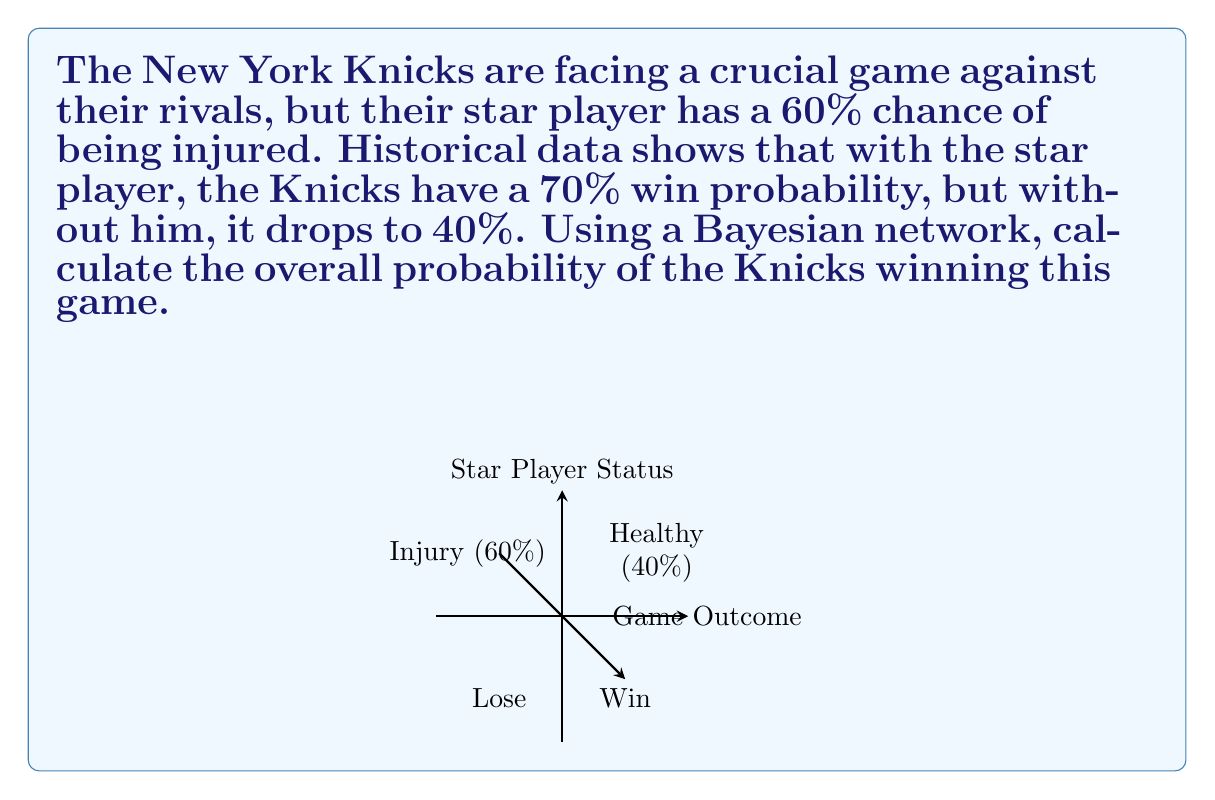Provide a solution to this math problem. Let's approach this step-by-step using Bayesian probability:

1) Define our events:
   I: Star player is injured
   W: Knicks win the game

2) Given probabilities:
   P(I) = 0.60 (60% chance of injury)
   P(W|I) = 0.40 (40% win probability if injured)
   P(W|not I) = 0.70 (70% win probability if not injured)

3) We need to find P(W), which can be calculated using the law of total probability:

   $$P(W) = P(W|I) \cdot P(I) + P(W|\text{not }I) \cdot P(\text{not }I)$$

4) We know P(I) = 0.60, so P(not I) = 1 - 0.60 = 0.40

5) Now, let's substitute the values:

   $$P(W) = 0.40 \cdot 0.60 + 0.70 \cdot 0.40$$

6) Calculate:
   $$P(W) = 0.24 + 0.28 = 0.52$$

Therefore, the overall probability of the Knicks winning this game is 0.52 or 52%.
Answer: 0.52 